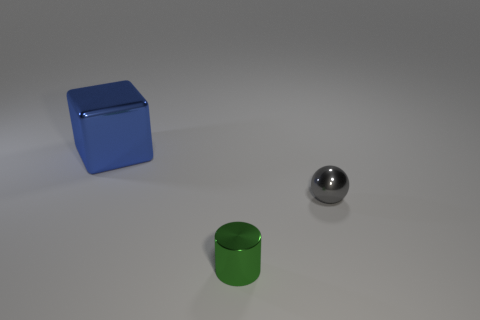Is there anything else that has the same size as the cube?
Ensure brevity in your answer.  No. There is a metallic thing that is to the right of the green metallic thing; is its size the same as the large metallic object?
Provide a succinct answer. No. The shiny object that is in front of the shiny block and behind the cylinder has what shape?
Provide a short and direct response. Sphere. There is a small thing in front of the object that is on the right side of the small object in front of the gray metal ball; what color is it?
Your answer should be compact. Green. Are there the same number of cylinders to the left of the big blue cube and yellow cylinders?
Make the answer very short. Yes. How many cubes are yellow objects or green metal objects?
Give a very brief answer. 0. There is a cube that is made of the same material as the small sphere; what color is it?
Provide a short and direct response. Blue. Is the material of the gray ball the same as the tiny object that is in front of the sphere?
Provide a succinct answer. Yes. How many objects are big yellow matte cubes or tiny metallic things?
Your answer should be very brief. 2. Are there any other small green objects of the same shape as the green object?
Offer a terse response. No. 